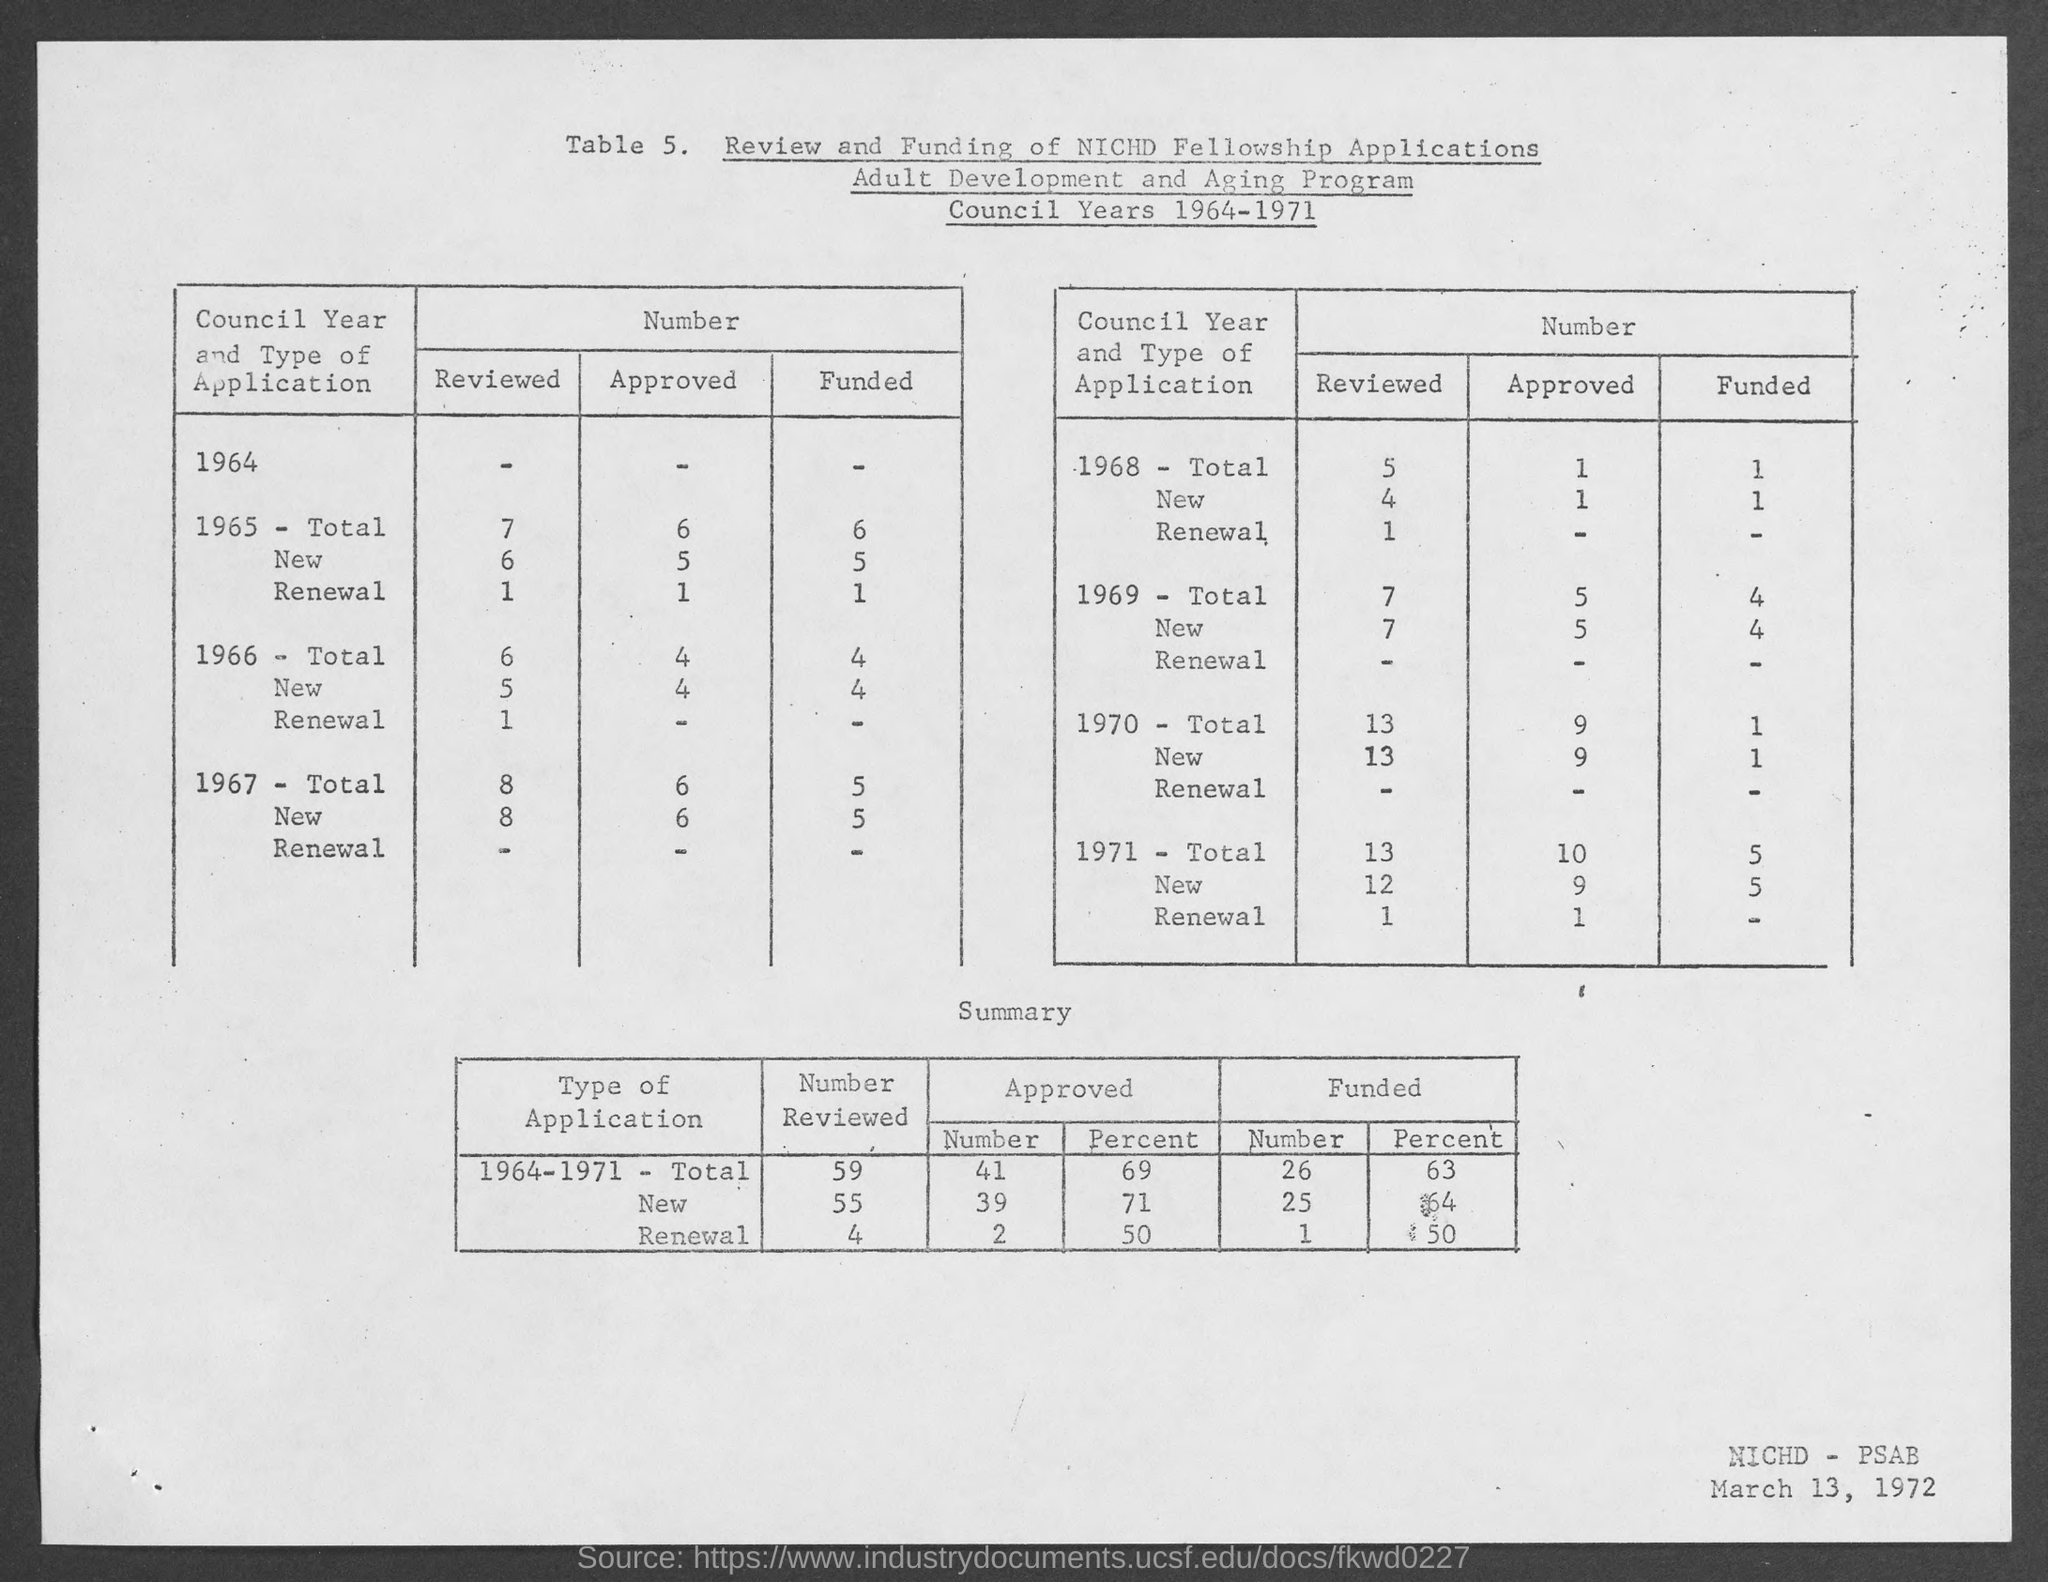List a handful of essential elements in this visual. The date at the bottom-right corner of the page is March 13, 1972. 